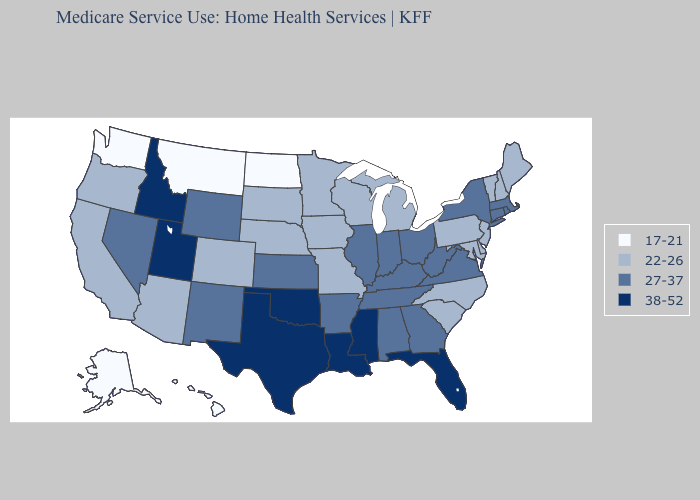What is the value of Michigan?
Quick response, please. 22-26. Does North Dakota have the lowest value in the MidWest?
Quick response, please. Yes. Among the states that border Mississippi , which have the highest value?
Quick response, please. Louisiana. What is the value of New Hampshire?
Write a very short answer. 22-26. What is the value of Utah?
Short answer required. 38-52. Which states hav the highest value in the West?
Concise answer only. Idaho, Utah. Does Arkansas have a lower value than Louisiana?
Keep it brief. Yes. What is the value of Oregon?
Be succinct. 22-26. Name the states that have a value in the range 17-21?
Be succinct. Alaska, Hawaii, Montana, North Dakota, Washington. Does New Jersey have the highest value in the Northeast?
Keep it brief. No. What is the highest value in the USA?
Be succinct. 38-52. Is the legend a continuous bar?
Short answer required. No. What is the value of California?
Answer briefly. 22-26. What is the highest value in the Northeast ?
Keep it brief. 27-37. What is the highest value in the USA?
Concise answer only. 38-52. 